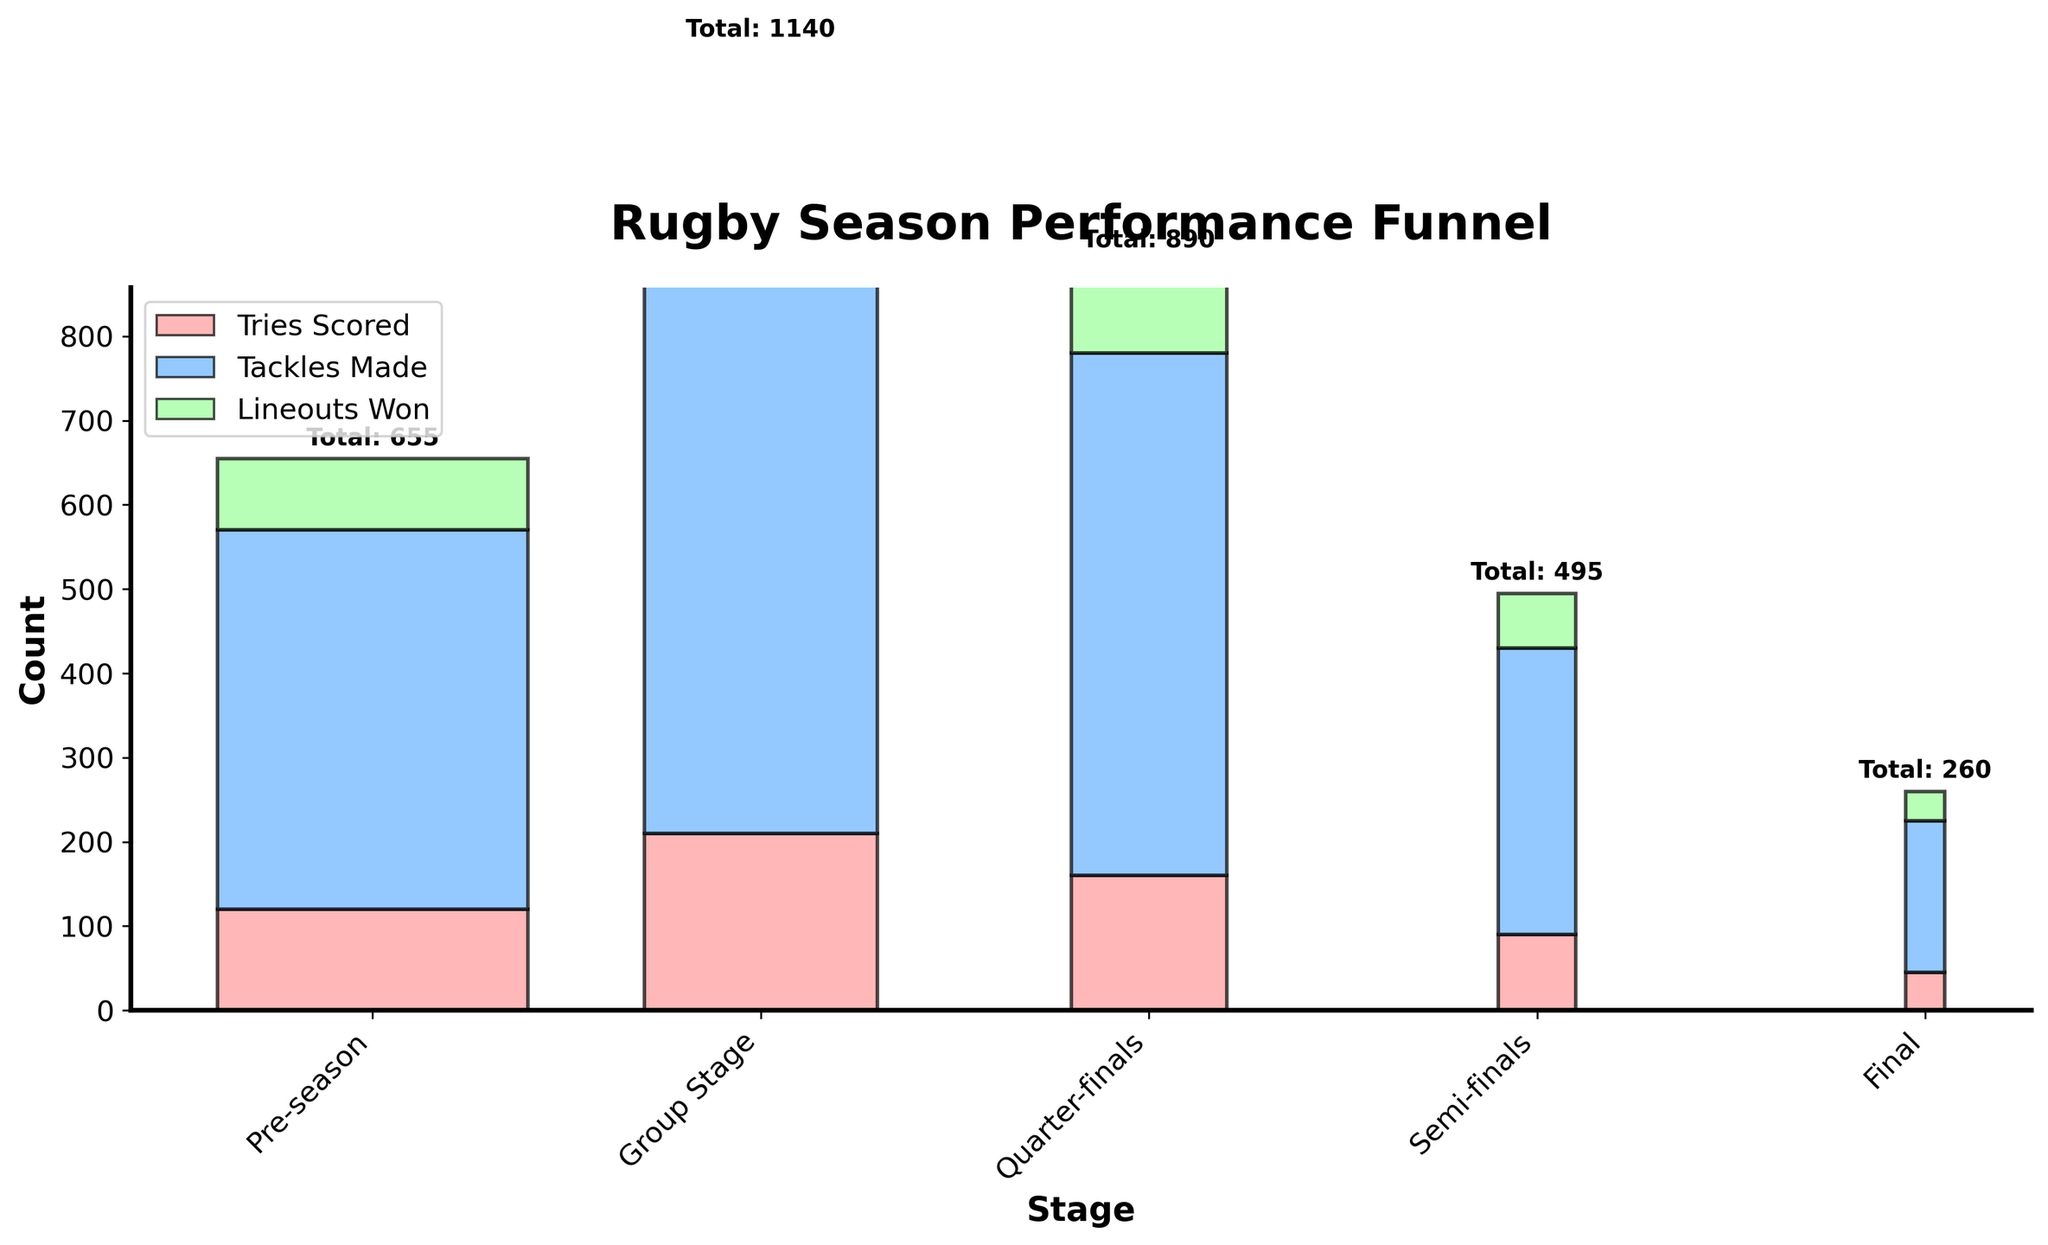What's the title of the figure? The title of the figure is displayed at the top in bold text.
Answer: "Rugby Season Performance Funnel" How many stages are shown in the figure? The x-axis of the funnel chart lists the stages.
Answer: Five What is the total number of tries scored in the group stage? Observe the height of the bar for "Tries Scored" in the Group Stage.
Answer: 210 How does the count of tackles made change as the stages progress? Examine the progression of the "Tackles Made" feature from Pre-season to Final.
Answer: Increases from Pre-season to Group Stage and decreases subsequently At which stage are the lineouts won the lowest? Look at the height of the "Lineouts Won" bar across all stages.
Answer: Final What is the total for all three statistics (tries scored, tackles made, and lineouts won) in the semi-finals? Add the values of the three statistics for the Semi-finals stage. 90 (tries) + 340 (tackles) + 65 (lineouts) = 495.
Answer: 495 How does the number of teams remaining compare between the quarter-finals and semi-finals? Compare the values shown for "Teams Remaining" at the Quarter-finals and Semi-finals stages.
Answer: There are 4 fewer teams in the Semi-finals compared to the Quarter-finals Which stage has the highest combined value for tries scored and tackles made? Compute the sum of "Tries Scored" and "Tackles Made" for each stage and find the maximum. Group Stage: 210 + 780 = 990, Quarter-finals: 160 + 620 = 780, etc. Highest is Group Stage.
Answer: Group Stage What is the overall trend in the total values of the statistics as the stages progress? Observe the total bar height at each stage from Pre-season to Final.
Answer: Initially increases and then decreases Is the decrease in tries scored from the Group Stage to the Final more or less than the decrease in tackles made for the same period? Calculate the difference in tries scored between Group Stage and Final (210 - 45 = 165) and the difference in tackles made (780 - 180 = 600). Compare the differences.
Answer: Tries scored decrease less 